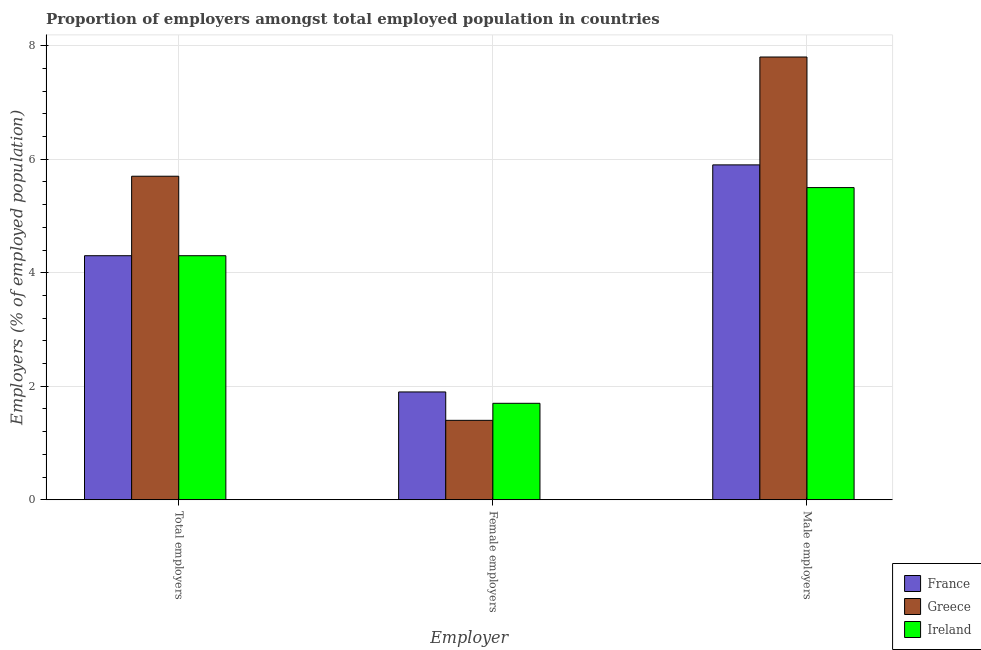How many groups of bars are there?
Keep it short and to the point. 3. Are the number of bars per tick equal to the number of legend labels?
Provide a succinct answer. Yes. What is the label of the 2nd group of bars from the left?
Your response must be concise. Female employers. What is the percentage of female employers in Ireland?
Make the answer very short. 1.7. Across all countries, what is the maximum percentage of female employers?
Provide a short and direct response. 1.9. In which country was the percentage of male employers maximum?
Provide a short and direct response. Greece. In which country was the percentage of female employers minimum?
Offer a terse response. Greece. What is the total percentage of male employers in the graph?
Make the answer very short. 19.2. What is the difference between the percentage of total employers in Ireland and that in France?
Keep it short and to the point. 0. What is the difference between the percentage of male employers in Greece and the percentage of total employers in Ireland?
Your answer should be compact. 3.5. What is the average percentage of male employers per country?
Your answer should be compact. 6.4. What is the difference between the percentage of male employers and percentage of total employers in Greece?
Your answer should be compact. 2.1. In how many countries, is the percentage of male employers greater than 2.4 %?
Offer a terse response. 3. What is the ratio of the percentage of male employers in Greece to that in Ireland?
Provide a short and direct response. 1.42. Is the percentage of total employers in Ireland less than that in France?
Offer a terse response. No. What is the difference between the highest and the second highest percentage of total employers?
Ensure brevity in your answer.  1.4. What is the difference between the highest and the lowest percentage of total employers?
Offer a very short reply. 1.4. In how many countries, is the percentage of total employers greater than the average percentage of total employers taken over all countries?
Offer a terse response. 1. Is the sum of the percentage of male employers in Ireland and Greece greater than the maximum percentage of female employers across all countries?
Make the answer very short. Yes. Is it the case that in every country, the sum of the percentage of total employers and percentage of female employers is greater than the percentage of male employers?
Your answer should be very brief. No. How many bars are there?
Your answer should be very brief. 9. Are all the bars in the graph horizontal?
Keep it short and to the point. No. How many countries are there in the graph?
Your answer should be very brief. 3. What is the difference between two consecutive major ticks on the Y-axis?
Your answer should be compact. 2. Does the graph contain grids?
Your response must be concise. Yes. Where does the legend appear in the graph?
Provide a short and direct response. Bottom right. What is the title of the graph?
Offer a terse response. Proportion of employers amongst total employed population in countries. Does "Georgia" appear as one of the legend labels in the graph?
Ensure brevity in your answer.  No. What is the label or title of the X-axis?
Give a very brief answer. Employer. What is the label or title of the Y-axis?
Provide a short and direct response. Employers (% of employed population). What is the Employers (% of employed population) in France in Total employers?
Provide a short and direct response. 4.3. What is the Employers (% of employed population) in Greece in Total employers?
Your response must be concise. 5.7. What is the Employers (% of employed population) of Ireland in Total employers?
Your answer should be compact. 4.3. What is the Employers (% of employed population) in France in Female employers?
Offer a terse response. 1.9. What is the Employers (% of employed population) in Greece in Female employers?
Your answer should be compact. 1.4. What is the Employers (% of employed population) of Ireland in Female employers?
Your answer should be very brief. 1.7. What is the Employers (% of employed population) in France in Male employers?
Ensure brevity in your answer.  5.9. What is the Employers (% of employed population) in Greece in Male employers?
Ensure brevity in your answer.  7.8. What is the Employers (% of employed population) of Ireland in Male employers?
Your answer should be compact. 5.5. Across all Employer, what is the maximum Employers (% of employed population) of France?
Your answer should be very brief. 5.9. Across all Employer, what is the maximum Employers (% of employed population) of Greece?
Provide a short and direct response. 7.8. Across all Employer, what is the maximum Employers (% of employed population) in Ireland?
Provide a succinct answer. 5.5. Across all Employer, what is the minimum Employers (% of employed population) in France?
Your answer should be compact. 1.9. Across all Employer, what is the minimum Employers (% of employed population) in Greece?
Ensure brevity in your answer.  1.4. Across all Employer, what is the minimum Employers (% of employed population) of Ireland?
Offer a terse response. 1.7. What is the total Employers (% of employed population) of Greece in the graph?
Your answer should be very brief. 14.9. What is the total Employers (% of employed population) of Ireland in the graph?
Your response must be concise. 11.5. What is the difference between the Employers (% of employed population) of Greece in Total employers and that in Female employers?
Give a very brief answer. 4.3. What is the difference between the Employers (% of employed population) in Ireland in Total employers and that in Male employers?
Your response must be concise. -1.2. What is the difference between the Employers (% of employed population) in France in Female employers and that in Male employers?
Provide a succinct answer. -4. What is the difference between the Employers (% of employed population) of Greece in Female employers and that in Male employers?
Ensure brevity in your answer.  -6.4. What is the difference between the Employers (% of employed population) in France in Total employers and the Employers (% of employed population) in Greece in Female employers?
Your answer should be very brief. 2.9. What is the difference between the Employers (% of employed population) of France in Total employers and the Employers (% of employed population) of Ireland in Female employers?
Your answer should be very brief. 2.6. What is the difference between the Employers (% of employed population) in France in Total employers and the Employers (% of employed population) in Greece in Male employers?
Your answer should be compact. -3.5. What is the difference between the Employers (% of employed population) in France in Female employers and the Employers (% of employed population) in Greece in Male employers?
Your answer should be very brief. -5.9. What is the difference between the Employers (% of employed population) in Greece in Female employers and the Employers (% of employed population) in Ireland in Male employers?
Offer a terse response. -4.1. What is the average Employers (% of employed population) in France per Employer?
Your answer should be very brief. 4.03. What is the average Employers (% of employed population) in Greece per Employer?
Your answer should be compact. 4.97. What is the average Employers (% of employed population) of Ireland per Employer?
Provide a short and direct response. 3.83. What is the difference between the Employers (% of employed population) in France and Employers (% of employed population) in Greece in Total employers?
Provide a succinct answer. -1.4. What is the difference between the Employers (% of employed population) of France and Employers (% of employed population) of Ireland in Total employers?
Provide a short and direct response. 0. What is the difference between the Employers (% of employed population) of Greece and Employers (% of employed population) of Ireland in Total employers?
Offer a terse response. 1.4. What is the difference between the Employers (% of employed population) of France and Employers (% of employed population) of Ireland in Female employers?
Provide a succinct answer. 0.2. What is the difference between the Employers (% of employed population) of Greece and Employers (% of employed population) of Ireland in Female employers?
Provide a short and direct response. -0.3. What is the difference between the Employers (% of employed population) in France and Employers (% of employed population) in Greece in Male employers?
Offer a very short reply. -1.9. What is the difference between the Employers (% of employed population) of Greece and Employers (% of employed population) of Ireland in Male employers?
Your answer should be compact. 2.3. What is the ratio of the Employers (% of employed population) in France in Total employers to that in Female employers?
Give a very brief answer. 2.26. What is the ratio of the Employers (% of employed population) in Greece in Total employers to that in Female employers?
Provide a succinct answer. 4.07. What is the ratio of the Employers (% of employed population) of Ireland in Total employers to that in Female employers?
Make the answer very short. 2.53. What is the ratio of the Employers (% of employed population) in France in Total employers to that in Male employers?
Offer a very short reply. 0.73. What is the ratio of the Employers (% of employed population) of Greece in Total employers to that in Male employers?
Give a very brief answer. 0.73. What is the ratio of the Employers (% of employed population) of Ireland in Total employers to that in Male employers?
Ensure brevity in your answer.  0.78. What is the ratio of the Employers (% of employed population) in France in Female employers to that in Male employers?
Give a very brief answer. 0.32. What is the ratio of the Employers (% of employed population) in Greece in Female employers to that in Male employers?
Your answer should be very brief. 0.18. What is the ratio of the Employers (% of employed population) of Ireland in Female employers to that in Male employers?
Give a very brief answer. 0.31. What is the difference between the highest and the second highest Employers (% of employed population) of Greece?
Offer a terse response. 2.1. 